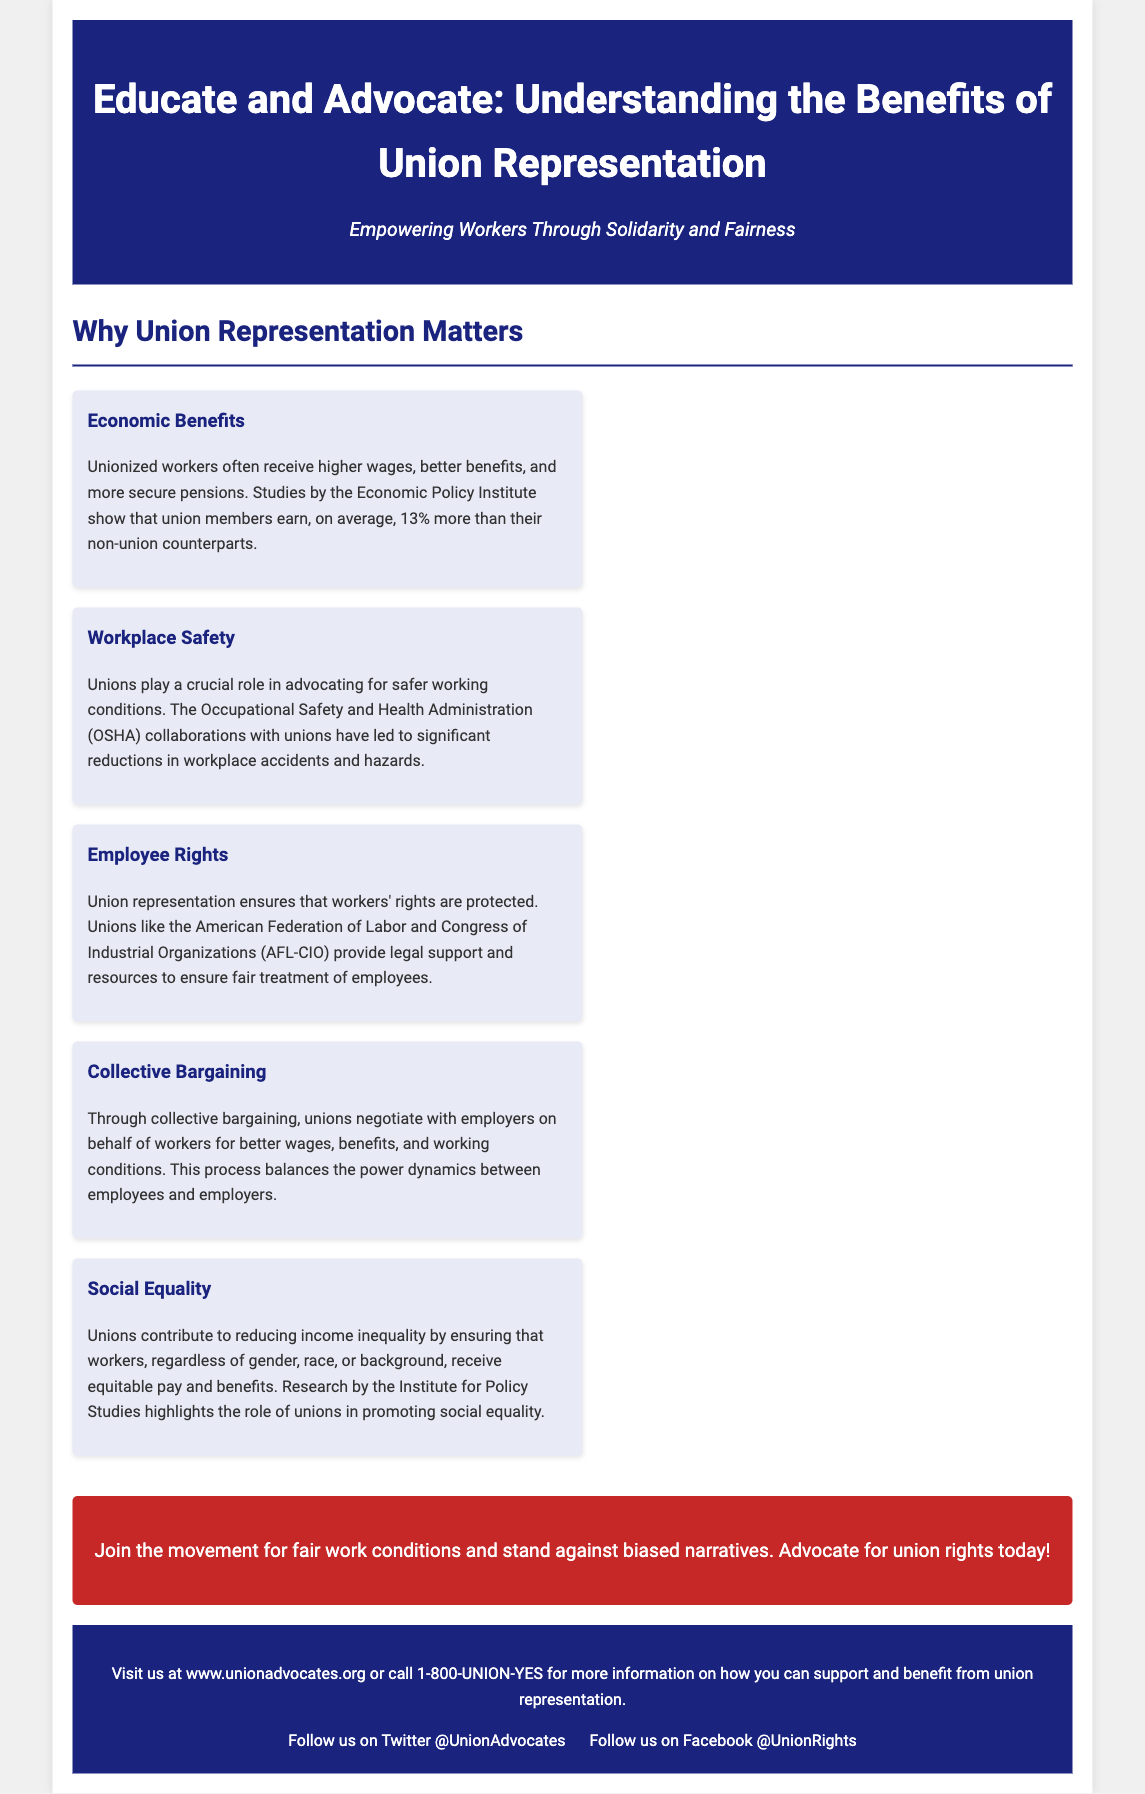What is the title of the document? The title is explicitly mentioned in the header section of the document.
Answer: Educate and Advocate: Understanding the Benefits of Union Representation What is the main subheadline? The subheadline supports the title and is presented just below it.
Answer: Empowering Workers Through Solidarity and Fairness What percentage more do union members earn compared to non-union counterparts? This information is provided in the Economic Benefits section of the document.
Answer: 13% Which organization collaborates with unions for workplace safety? The document states this collaboration in the Workplace Safety section.
Answer: OSHA What is one role that unions play in relation to employee rights? This is explained in the Employee Rights section of the document.
Answer: Legal support What benefit does collective bargaining provide to workers? The benefit is mentioned in the Collective Bargaining section of the document.
Answer: Better wages, benefits, and working conditions How do unions promote social equality? This is outlined in the Social Equality section of the document.
Answer: By ensuring equitable pay and benefits What action does the document encourage readers to take? This is stated in the call-to-action section of the document.
Answer: Advocate for union rights How can you contact Union Advocates for more information? This contact information is found in the footer section of the document.
Answer: 1-800-UNION-YES 